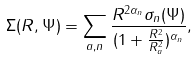<formula> <loc_0><loc_0><loc_500><loc_500>\Sigma ( R , \Psi ) = \sum _ { a , n } \frac { R ^ { 2 \alpha _ { n } } \sigma _ { n } ( \Psi ) } { ( 1 + \frac { R ^ { 2 } } { R _ { a } ^ { 2 } } ) ^ { \alpha _ { n } } } ,</formula> 